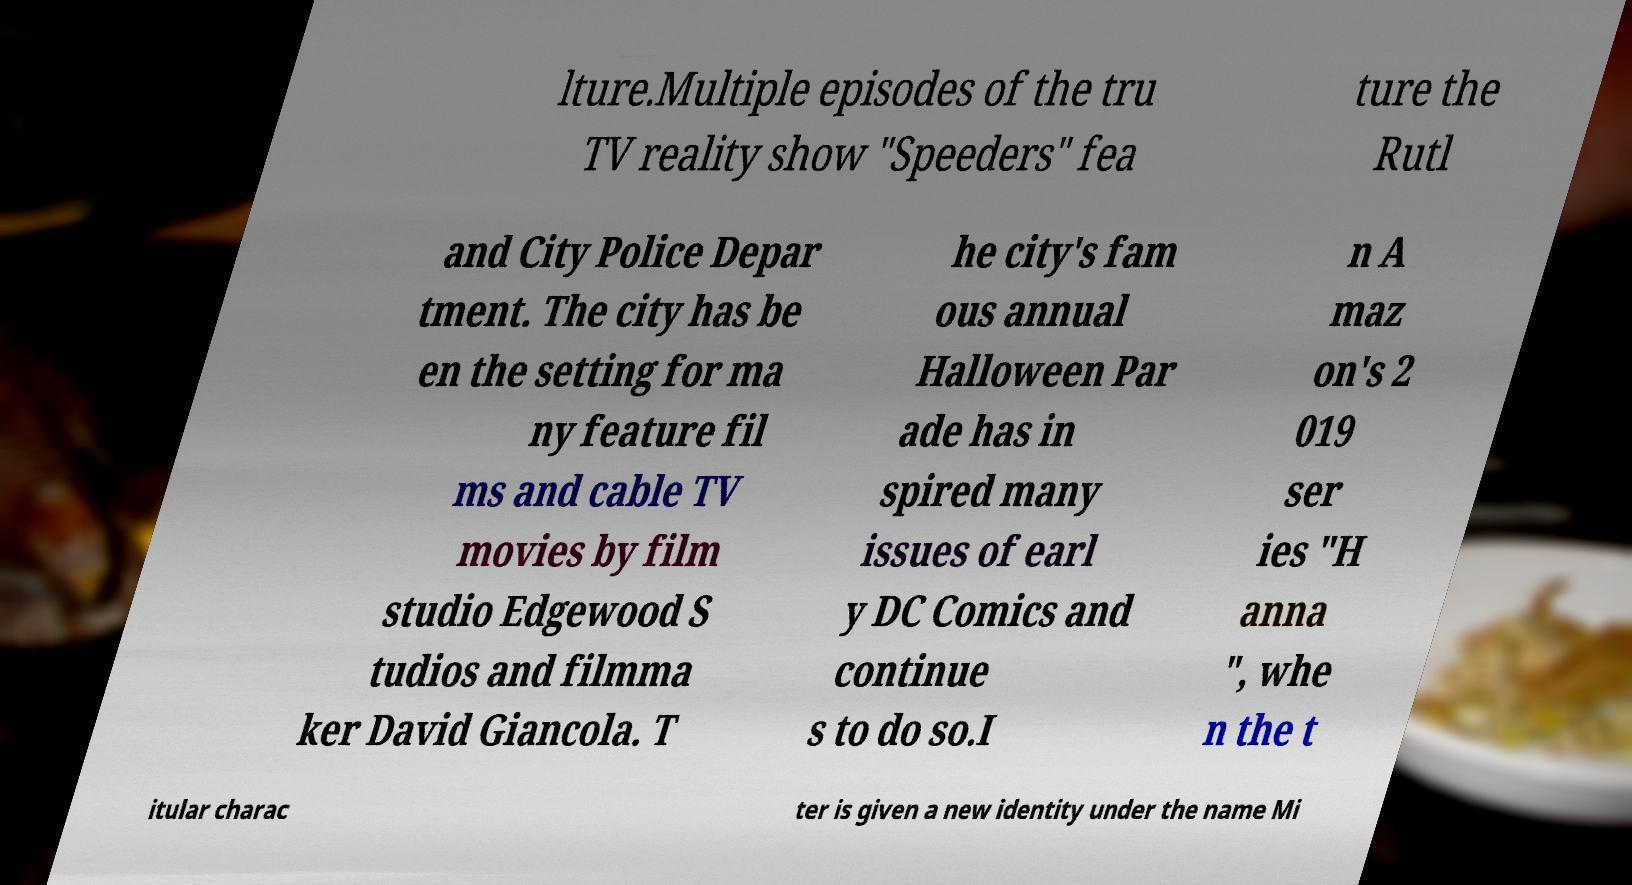Please read and relay the text visible in this image. What does it say? lture.Multiple episodes of the tru TV reality show "Speeders" fea ture the Rutl and City Police Depar tment. The city has be en the setting for ma ny feature fil ms and cable TV movies by film studio Edgewood S tudios and filmma ker David Giancola. T he city's fam ous annual Halloween Par ade has in spired many issues of earl y DC Comics and continue s to do so.I n A maz on's 2 019 ser ies "H anna ", whe n the t itular charac ter is given a new identity under the name Mi 